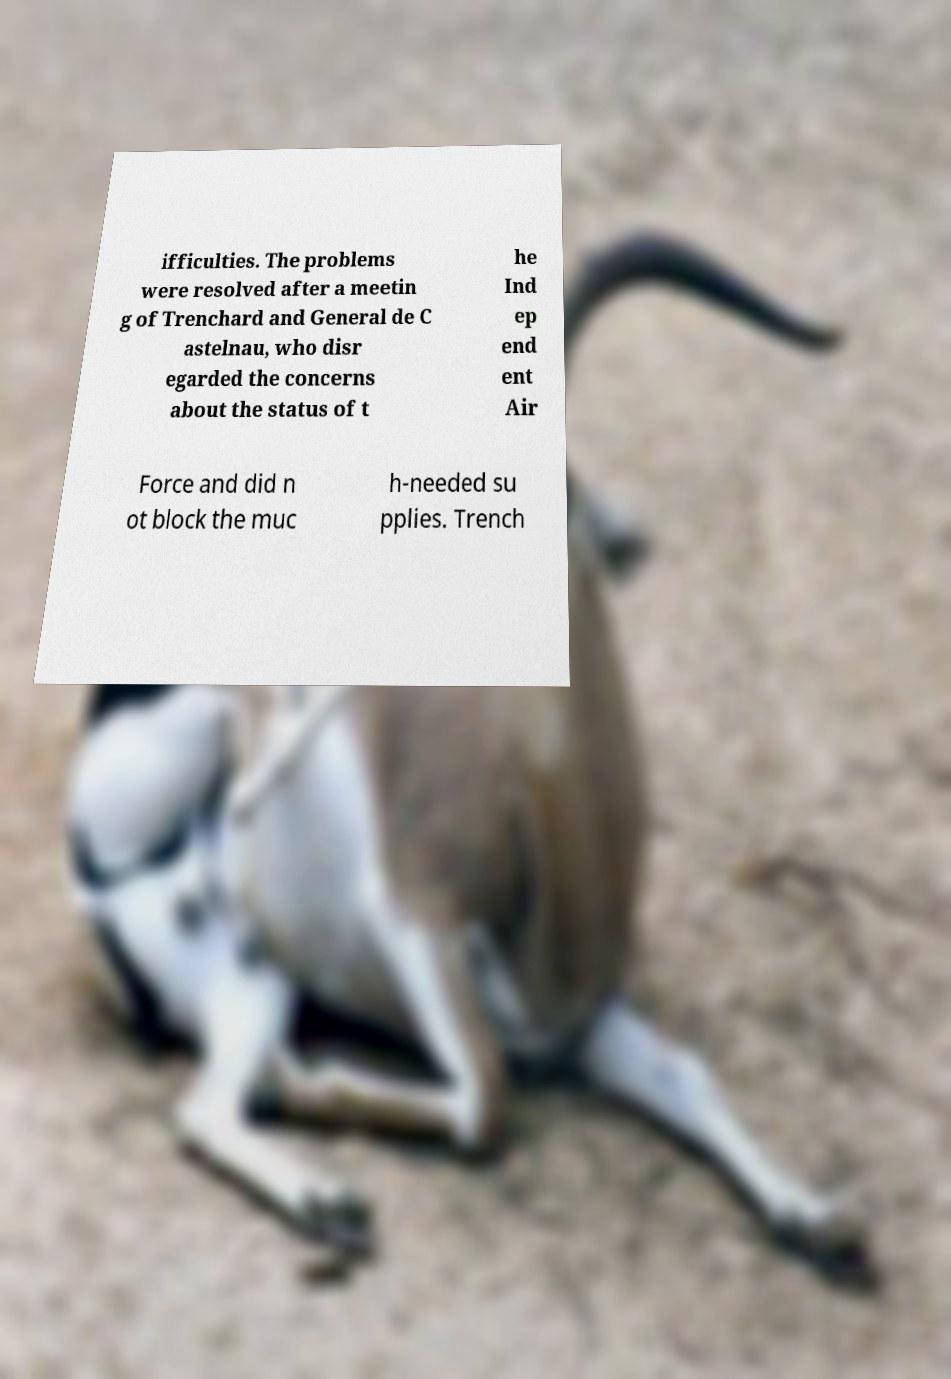Could you extract and type out the text from this image? ifficulties. The problems were resolved after a meetin g of Trenchard and General de C astelnau, who disr egarded the concerns about the status of t he Ind ep end ent Air Force and did n ot block the muc h-needed su pplies. Trench 